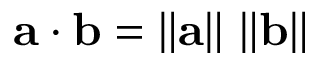<formula> <loc_0><loc_0><loc_500><loc_500>a \cdot b = \left \| a \right \| \, \left \| b \right \|</formula> 